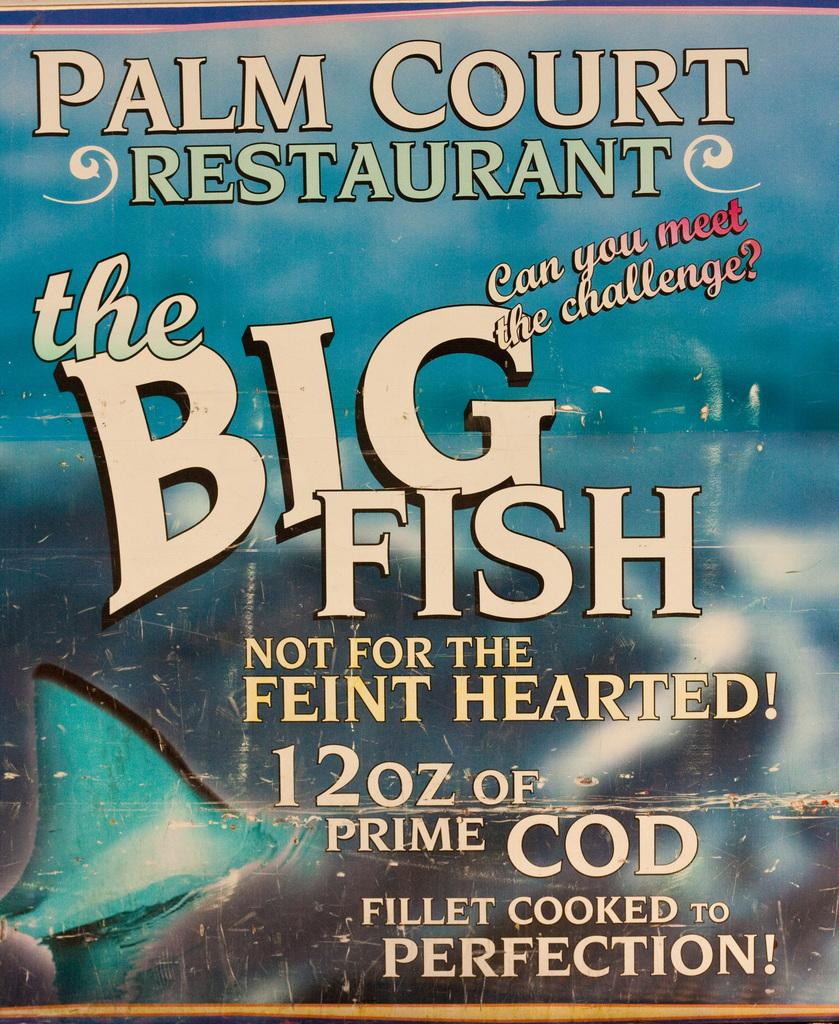What type of image is featured on the poster? The poster contains an animated image. What else is present on the poster besides the image? The poster contains text. How would you describe the quality of the animated image on the poster? The animated image is blurred. Can you hear the ground in the image? There is no sound or audio present in the image, so it is not possible to hear the ground. 